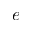Convert formula to latex. <formula><loc_0><loc_0><loc_500><loc_500>e</formula> 